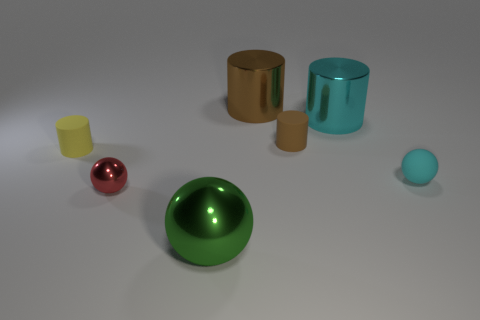How many small rubber cylinders are the same color as the small rubber ball?
Make the answer very short. 0. There is a big cylinder that is the same color as the rubber sphere; what material is it?
Your response must be concise. Metal. What number of shiny things are either big cylinders or big cyan things?
Your response must be concise. 2. Do the large object in front of the yellow object and the small thing that is in front of the small cyan object have the same shape?
Ensure brevity in your answer.  Yes. There is a green ball; how many matte cylinders are left of it?
Give a very brief answer. 1. Is there a large cylinder made of the same material as the big sphere?
Offer a terse response. Yes. What is the material of the brown cylinder that is the same size as the green shiny thing?
Provide a succinct answer. Metal. Do the big cyan thing and the yellow object have the same material?
Ensure brevity in your answer.  No. How many things are either small purple things or small rubber things?
Keep it short and to the point. 3. What is the shape of the big metal thing to the left of the large brown metal thing?
Provide a short and direct response. Sphere. 